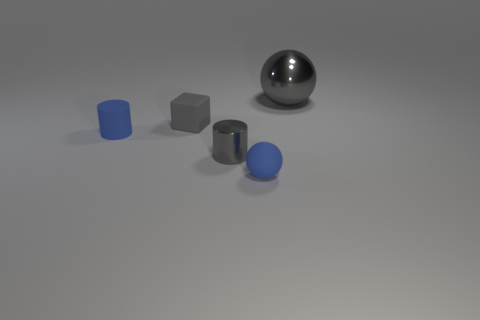Add 1 large yellow rubber cubes. How many objects exist? 6 Subtract all cubes. How many objects are left? 4 Add 2 big red shiny things. How many big red shiny things exist? 2 Subtract 1 blue spheres. How many objects are left? 4 Subtract all big gray metallic objects. Subtract all blue shiny spheres. How many objects are left? 4 Add 2 metal cylinders. How many metal cylinders are left? 3 